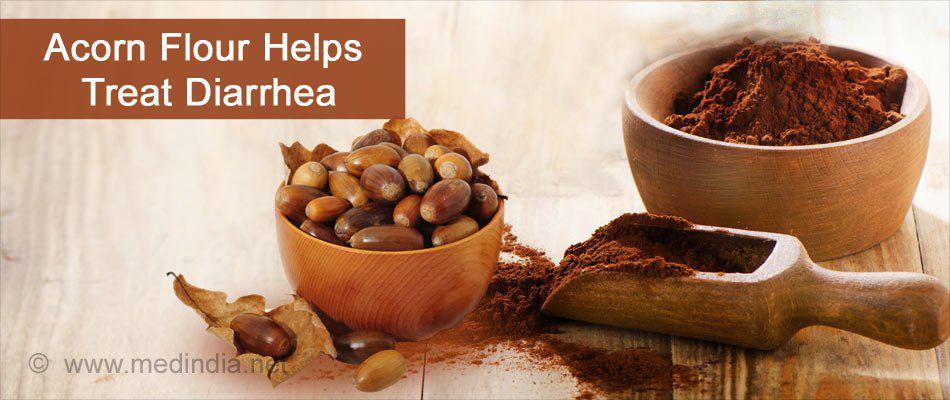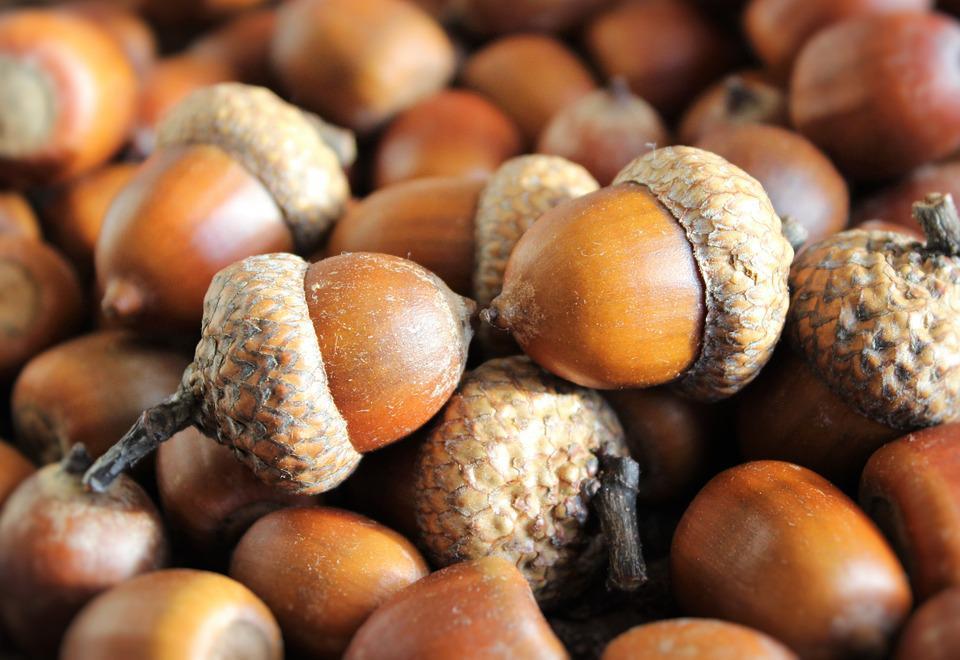The first image is the image on the left, the second image is the image on the right. Examine the images to the left and right. Is the description "The right image shows no more than three acorns on an autumn leaf, and the left image features acorn shapes that aren't really acorns." accurate? Answer yes or no. No. The first image is the image on the left, the second image is the image on the right. Considering the images on both sides, is "One of the images is food made to look like acorns." valid? Answer yes or no. No. 